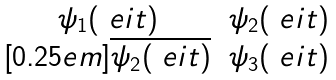Convert formula to latex. <formula><loc_0><loc_0><loc_500><loc_500>\begin{matrix} \psi _ { 1 } ( \ e i t ) & \psi _ { 2 } ( \ e i t ) \\ [ 0 . 2 5 e m ] \overline { \psi _ { 2 } ( \ e i t ) } & \psi _ { 3 } ( \ e i t ) \end{matrix}</formula> 